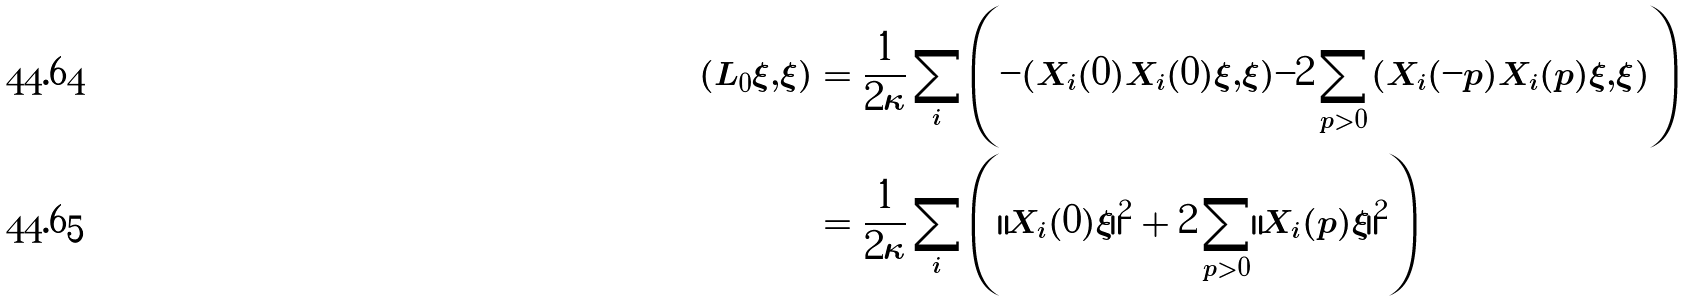Convert formula to latex. <formula><loc_0><loc_0><loc_500><loc_500>( L _ { 0 } \xi , \xi ) & = \frac { 1 } { 2 \kappa } \sum _ { i } \left ( - ( X _ { i } ( 0 ) X _ { i } ( 0 ) \xi , \xi ) - 2 \sum _ { p > 0 } ( X _ { i } ( - p ) X _ { i } ( p ) \xi , \xi ) \right ) \\ & = \frac { 1 } { 2 \kappa } \sum _ { i } \left ( \| X _ { i } ( 0 ) \xi \| ^ { 2 } + 2 \sum _ { p > 0 } \| X _ { i } ( p ) \xi \| ^ { 2 } \right )</formula> 